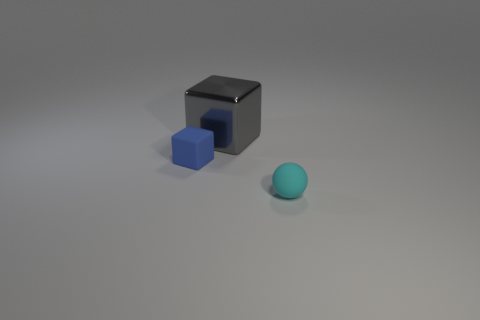Add 1 gray metallic blocks. How many objects exist? 4 Subtract all spheres. How many objects are left? 2 Add 1 small gray matte objects. How many small gray matte objects exist? 1 Subtract 0 yellow cylinders. How many objects are left? 3 Subtract all tiny cubes. Subtract all small brown rubber spheres. How many objects are left? 2 Add 2 blue blocks. How many blue blocks are left? 3 